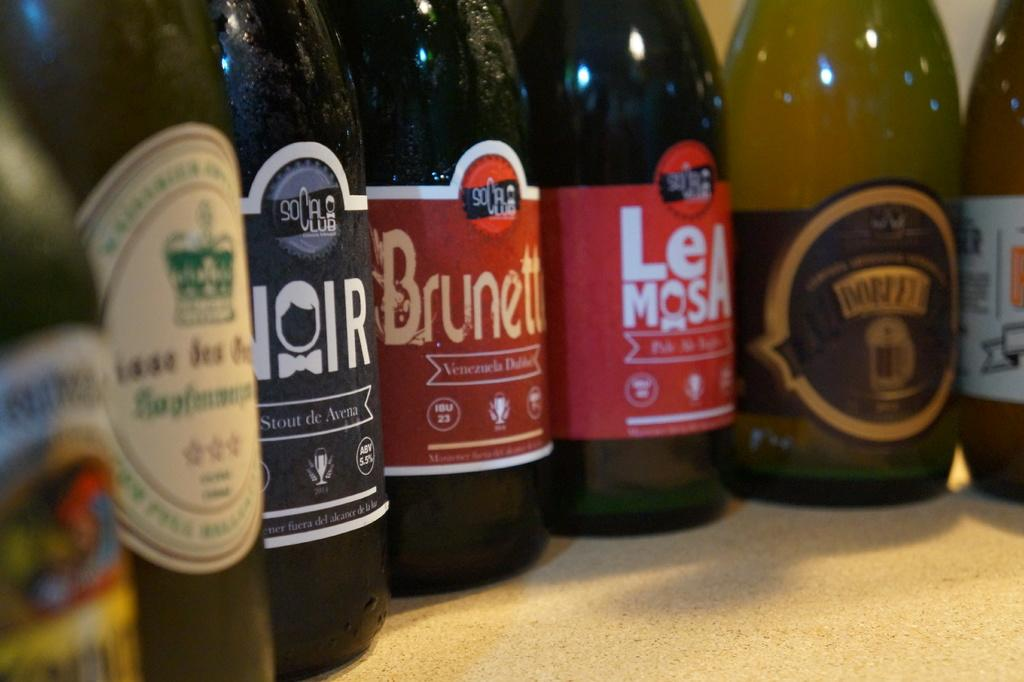What is the main subject of the image? The main subject of the image is many bottles. Can you describe the appearance of the bottles? The bottles have different colors. Are there any additional features on the bottles? Yes, there are labels on the bottles. What type of hose is connected to the bottles in the image? There is no hose connected to the bottles in the image. How many thumbs does the servant have in the image? There is no servant present in the image. 